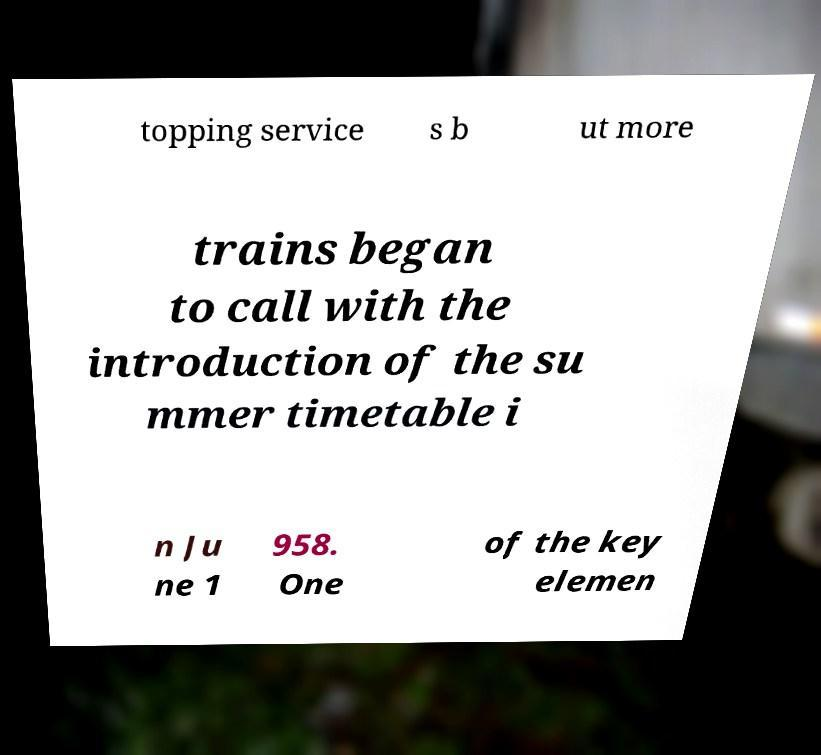For documentation purposes, I need the text within this image transcribed. Could you provide that? topping service s b ut more trains began to call with the introduction of the su mmer timetable i n Ju ne 1 958. One of the key elemen 